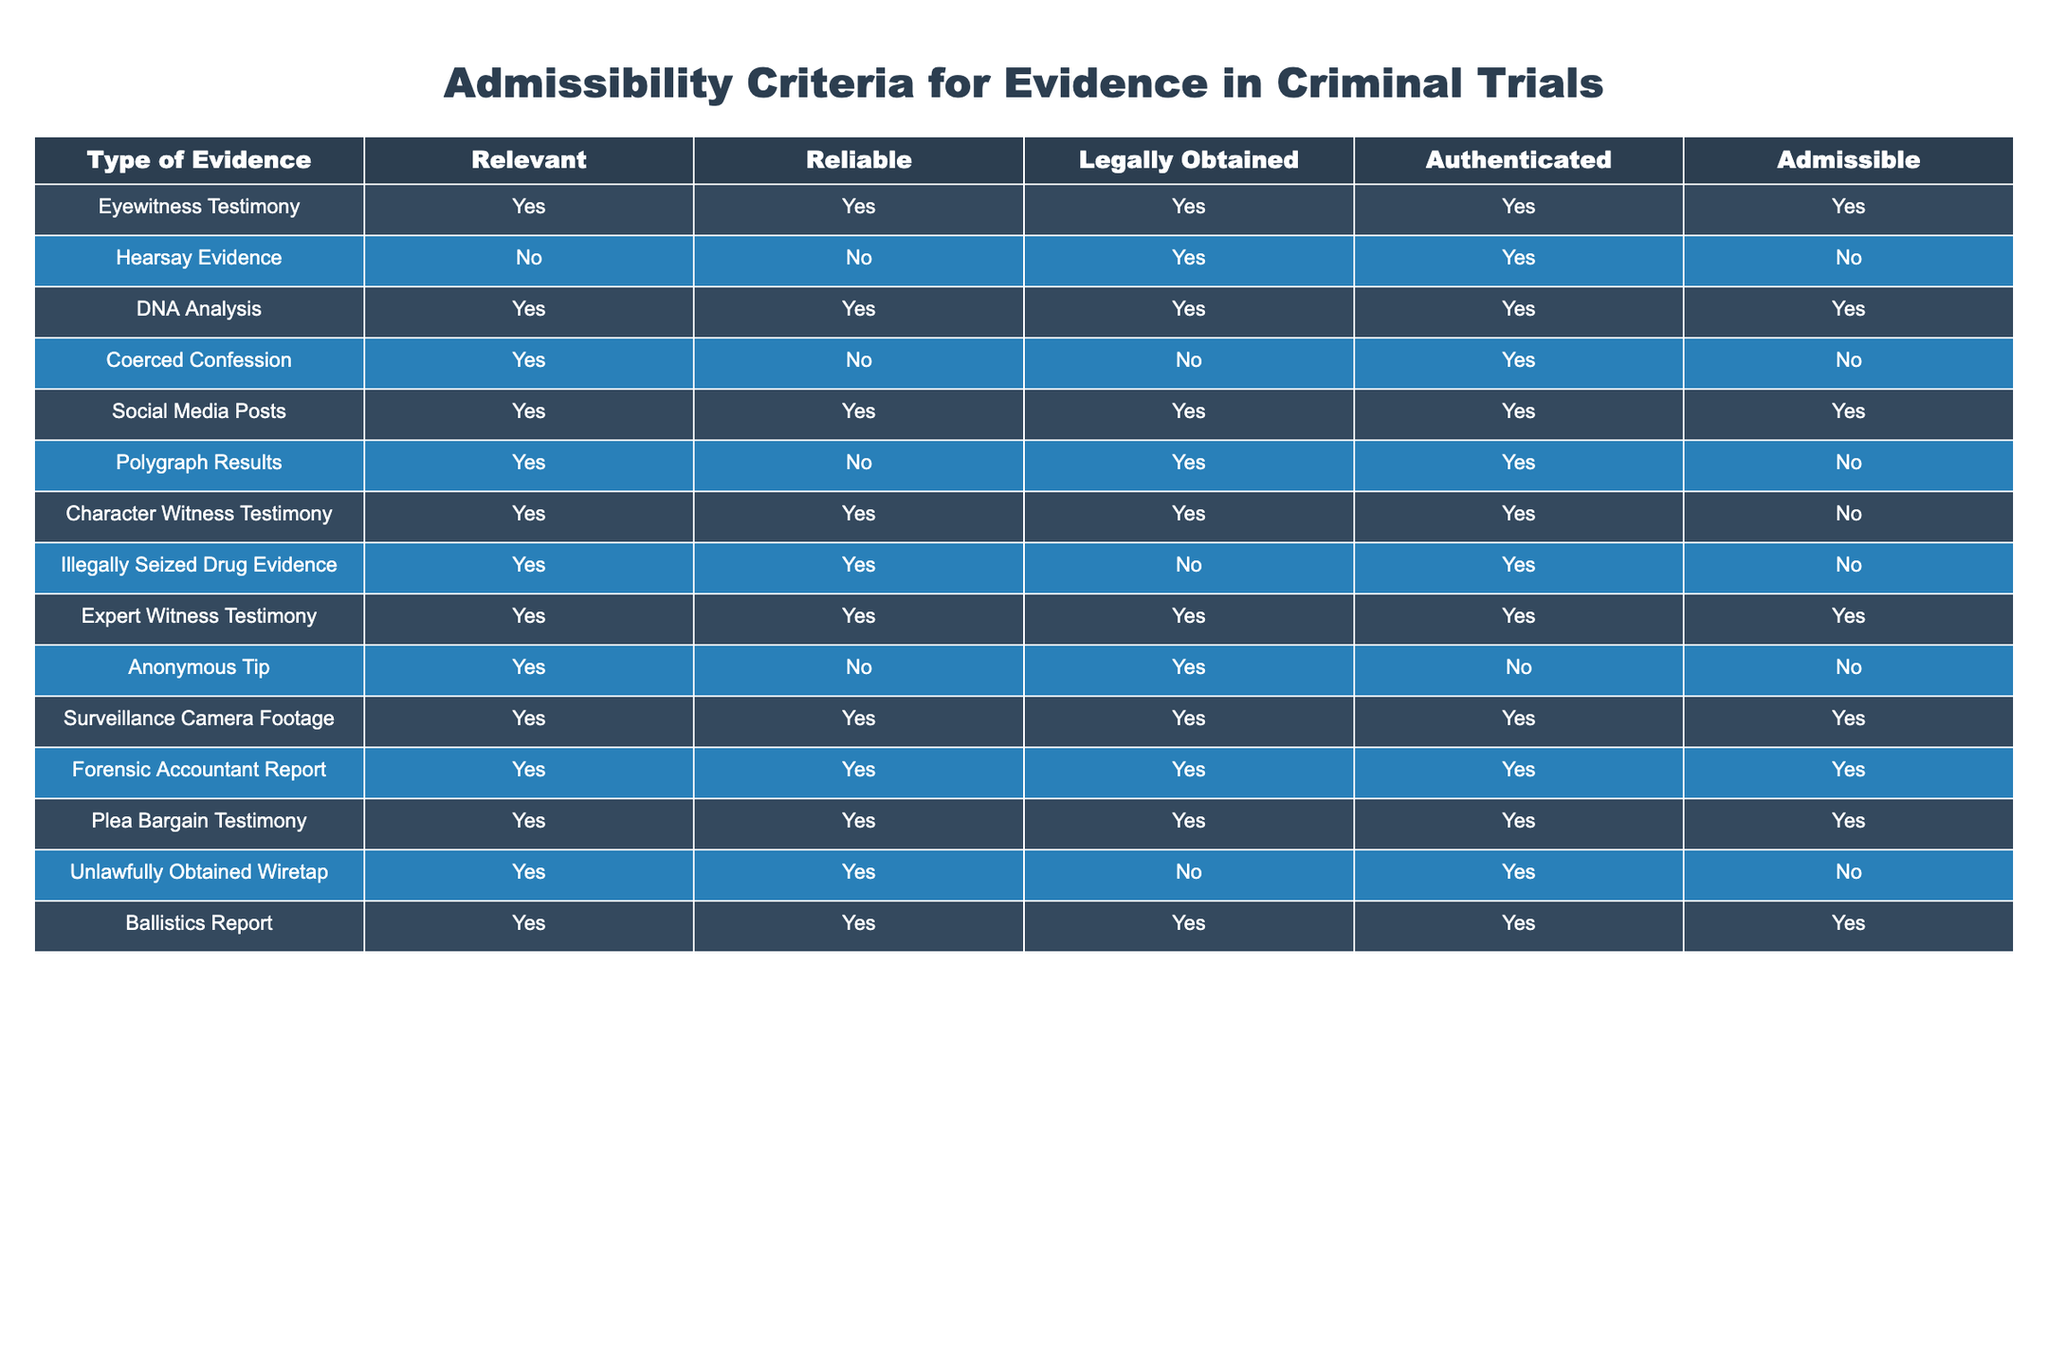What types of evidence are admissible in criminal trials? The admissible evidence types listed in the table are Eyewitness Testimony, DNA Analysis, Social Media Posts, Expert Witness Testimony, Plea Bargain Testimony, Surveillance Camera Footage, Forensic Accountant Report, and Ballistics Report.
Answer: Eyewitness Testimony, DNA Analysis, Social Media Posts, Expert Witness Testimony, Plea Bargain Testimony, Surveillance Camera Footage, Forensic Accountant Report, Ballistics Report Is hearsay evidence legally obtained? According to the table, hearsay evidence is labeled as legally obtained (TRUE), even though it fails other criteria like relevance and reliability, leading to its overall inadmissibility in court.
Answer: Yes How many types of evidence are not admissible? Looking at the table, there are 4 types of evidence marked as not admissible: hearsay evidence, coerced confession, character witness testimony, and unlawfully obtained wiretap. Thus, the total is 4.
Answer: 4 Which types of evidence are both reliable and admissible? From the table, the types of evidence that are both reliable (TRUE) and admissible (TRUE) are Eyewitness Testimony, DNA Analysis, Social Media Posts, Expert Witness Testimony, Plea Bargain Testimony, Surveillance Camera Footage, Forensic Accountant Report, and Ballistics Report.
Answer: Eyewitness Testimony, DNA Analysis, Social Media Posts, Expert Witness Testimony, Plea Bargain Testimony, Surveillance Camera Footage, Forensic Accountant Report, Ballistics Report Do any types of evidence show the criteria of being relevant but not reliable? The table shows two types of evidence that are relevant (TRUE) but not reliable (FALSE): Coerced Confession and Polygraph Results. This shows that despite relevance, these types cannot be trusted, thus affecting their admissibility.
Answer: Yes 